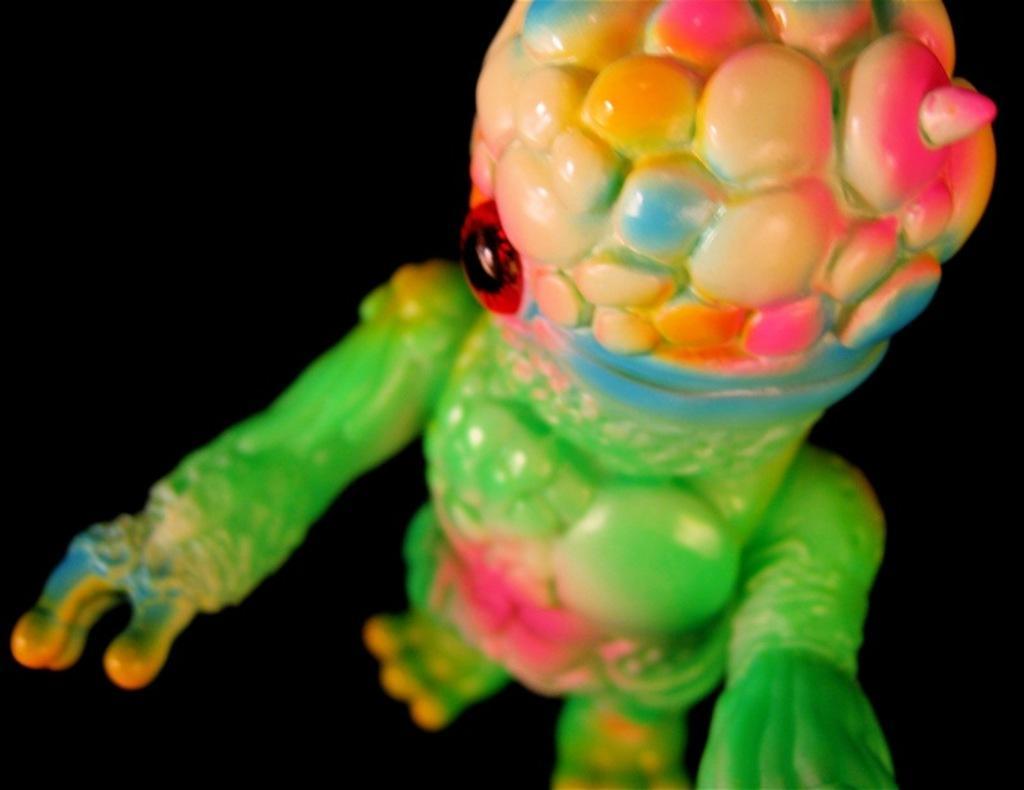Can you describe this image briefly? In this image we can see a toy and dark background. 